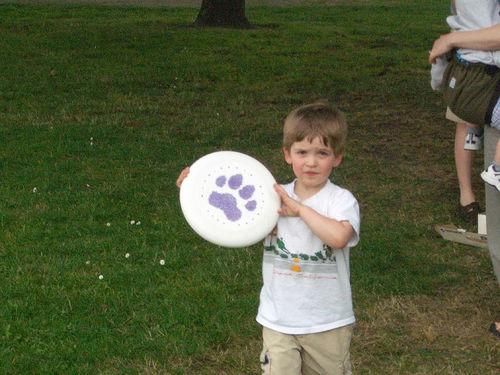Does the person holding the frisbee need help?
Short answer required. No. What type of top is the child wearing?
Short answer required. T shirt. Is a teenager holding a frisbee?
Short answer required. No. What is the name of the type of clothing the boy is wearing on his bottom half?
Write a very short answer. Shorts. What animal is on the frisbee?
Write a very short answer. Dog. Can this symbol be used for a sports team called the Tigers?
Give a very brief answer. Yes. 